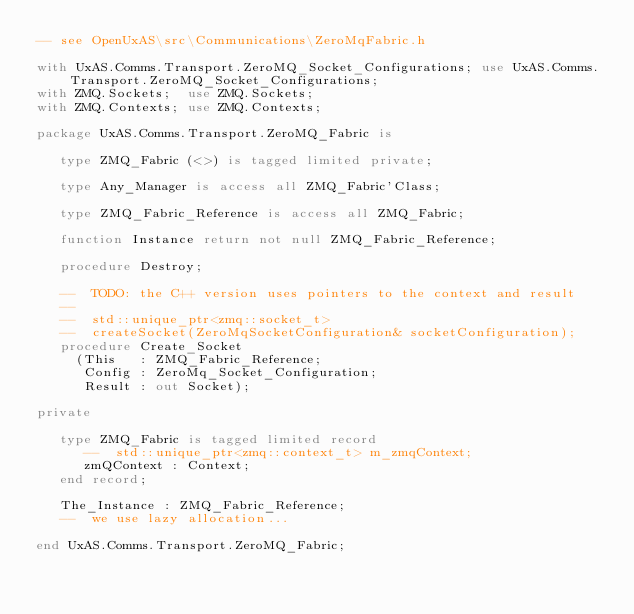Convert code to text. <code><loc_0><loc_0><loc_500><loc_500><_Ada_>-- see OpenUxAS\src\Communications\ZeroMqFabric.h

with UxAS.Comms.Transport.ZeroMQ_Socket_Configurations; use UxAS.Comms.Transport.ZeroMQ_Socket_Configurations;
with ZMQ.Sockets;  use ZMQ.Sockets;
with ZMQ.Contexts; use ZMQ.Contexts;

package UxAS.Comms.Transport.ZeroMQ_Fabric is

   type ZMQ_Fabric (<>) is tagged limited private;

   type Any_Manager is access all ZMQ_Fabric'Class;

   type ZMQ_Fabric_Reference is access all ZMQ_Fabric;

   function Instance return not null ZMQ_Fabric_Reference;

   procedure Destroy;

   --  TODO: the C++ version uses pointers to the context and result
   --
   --  std::unique_ptr<zmq::socket_t>
   --  createSocket(ZeroMqSocketConfiguration& socketConfiguration);
   procedure Create_Socket
     (This   : ZMQ_Fabric_Reference;
      Config : ZeroMq_Socket_Configuration;
      Result : out Socket);

private

   type ZMQ_Fabric is tagged limited record
      --  std::unique_ptr<zmq::context_t> m_zmqContext;
      zmQContext : Context;
   end record;

   The_Instance : ZMQ_Fabric_Reference;
   --  we use lazy allocation...

end UxAS.Comms.Transport.ZeroMQ_Fabric;
</code> 